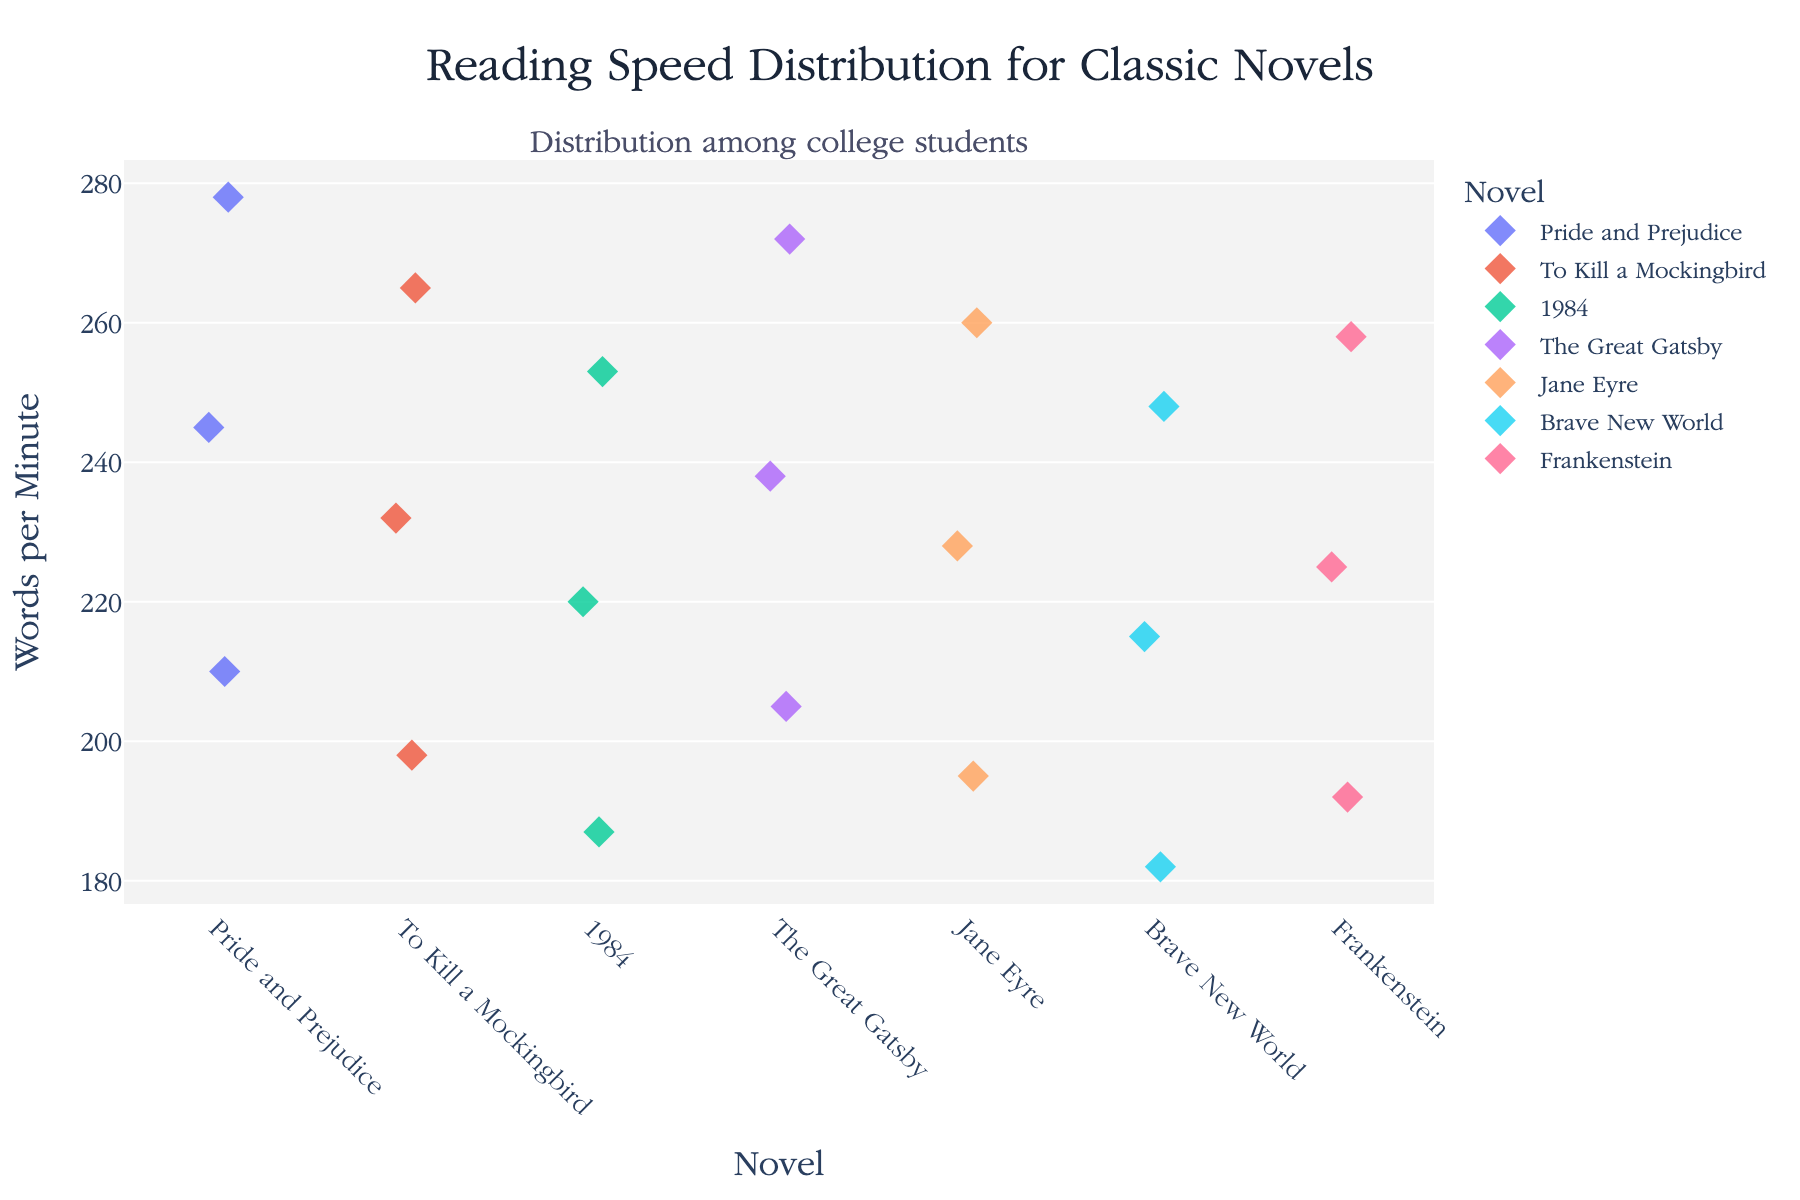What's the title of the plot? The title is usually displayed at the top of the figure and summarizes the content. In this case, it reads "Reading Speed Distribution for Classic Novels".
Answer: Reading Speed Distribution for Classic Novels Which novel shows the highest reading speed? Look for the highest data point on the y-axis and find which novel it corresponds to on the x-axis. The highest reading speed is around 278 words per minute, corresponding to "Pride and Prejudice".
Answer: Pride and Prejudice How many data points are there for "1984"? Count all the individual points (diamonds) that are in line with "1984" on the x-axis. There are three points visible.
Answer: 3 What is the approximate average reading speed for "Frankenstein"? To find the average, add the reading speeds for "Frankenstein" (225 + 258 + 192) and divide by the number of data points, which is 3. (225 + 258 + 192) / 3 = 225
Answer: 225 Which novel has the widest range of reading speeds? Look at the spread of points for each novel and identify the one with the largest distance between the lowest and highest points. "Pride and Prejudice" seems to have the widest range, from about 210 to 278 words per minute.
Answer: Pride and Prejudice Which novels have similar ranges of reading speeds? Compare the range of points for each novel. "1984" and "Brave New World" appear to have similar ranges of reading speed, both roughly between 187 to 253 and 182 to 248 words per minute, respectively.
Answer: 1984 and Brave New World Is there any novel where the reading speeds are closely clustered around a similar value? Look for sets of points for any novel that are close to each other without much spread. "Jane Eyre," with speeds around 228, 260, and 195 words per minute, shows relatively clustered data.
Answer: Jane Eyre Which novel has the lowest reading speed and how much is it? Look for the lowest data point on the y-axis and identify the corresponding novel. The lowest reading speed is about 182 words per minute for "Brave New World".
Answer: Brave New World What is the approximate median reading speed for "To Kill a Mockingbird"? To find the median, arrange the reading speeds in numerical order (198, 232, 265) and pick the middle one. The median value is 232 words per minute.
Answer: 232 Are there any outliers in the reading speed data? If so, which novels? Outliers are significantly different from the other data points. For instance, the lowest reading speed (182) for "Brave New World" and the highest (278) for "Pride and Prejudice" could be considered outliers.
Answer: Brave New World and Pride and Prejudice 